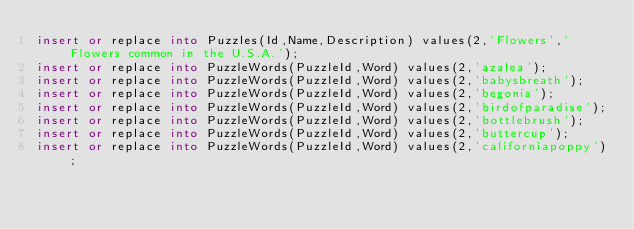<code> <loc_0><loc_0><loc_500><loc_500><_SQL_>insert or replace into Puzzles(Id,Name,Description) values(2,'Flowers','Flowers common in the U.S.A.');
insert or replace into PuzzleWords(PuzzleId,Word) values(2,'azalea');
insert or replace into PuzzleWords(PuzzleId,Word) values(2,'babysbreath');
insert or replace into PuzzleWords(PuzzleId,Word) values(2,'begonia');
insert or replace into PuzzleWords(PuzzleId,Word) values(2,'birdofparadise');
insert or replace into PuzzleWords(PuzzleId,Word) values(2,'bottlebrush');
insert or replace into PuzzleWords(PuzzleId,Word) values(2,'buttercup');
insert or replace into PuzzleWords(PuzzleId,Word) values(2,'californiapoppy');</code> 